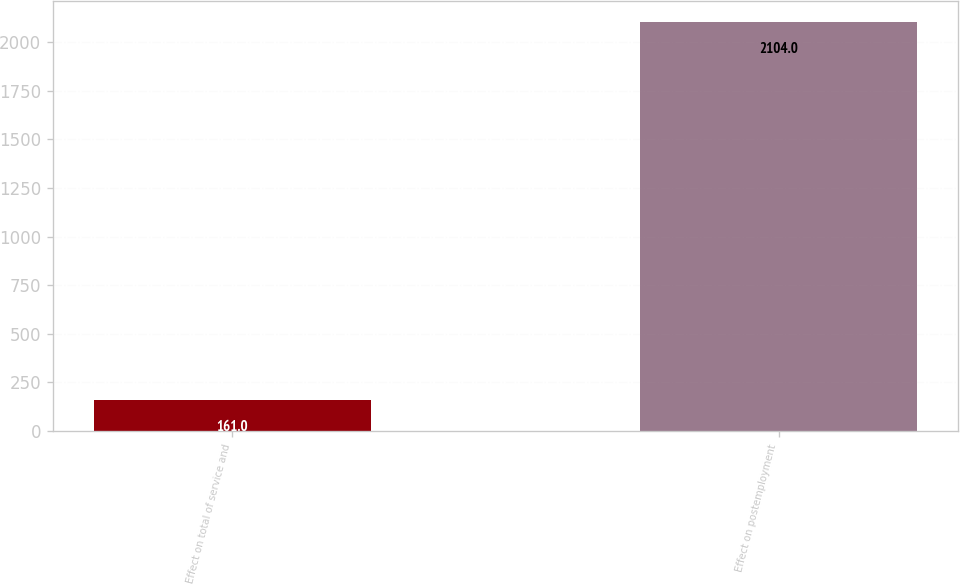<chart> <loc_0><loc_0><loc_500><loc_500><bar_chart><fcel>Effect on total of service and<fcel>Effect on postemployment<nl><fcel>161<fcel>2104<nl></chart> 